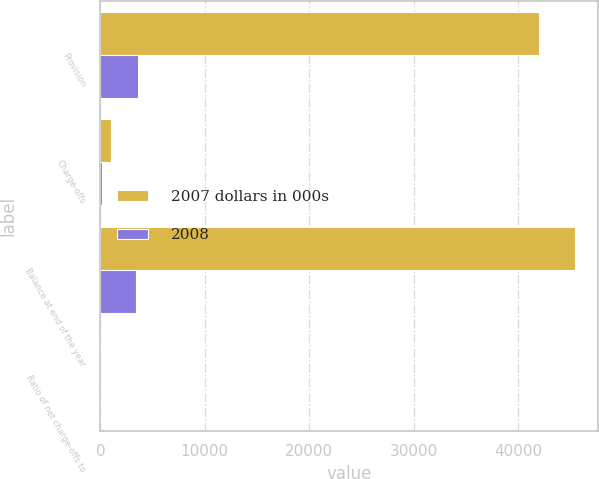Convert chart. <chart><loc_0><loc_0><loc_500><loc_500><stacked_bar_chart><ecel><fcel>Provision<fcel>Charge-offs<fcel>Balance at end of the year<fcel>Ratio of net charge-offs to<nl><fcel>2007 dollars in 000s<fcel>42004<fcel>1050<fcel>45401<fcel>0.09<nl><fcel>2008<fcel>3622<fcel>174<fcel>3448<fcel>0.02<nl></chart> 